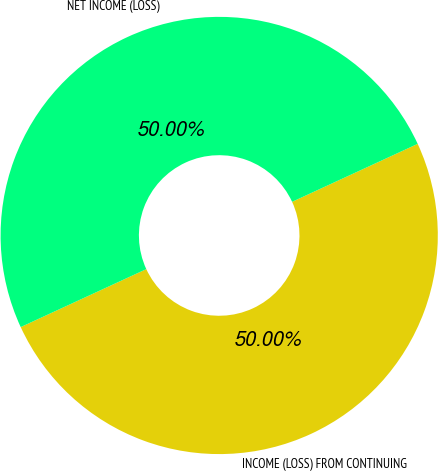<chart> <loc_0><loc_0><loc_500><loc_500><pie_chart><fcel>INCOME (LOSS) FROM CONTINUING<fcel>NET INCOME (LOSS)<nl><fcel>50.0%<fcel>50.0%<nl></chart> 